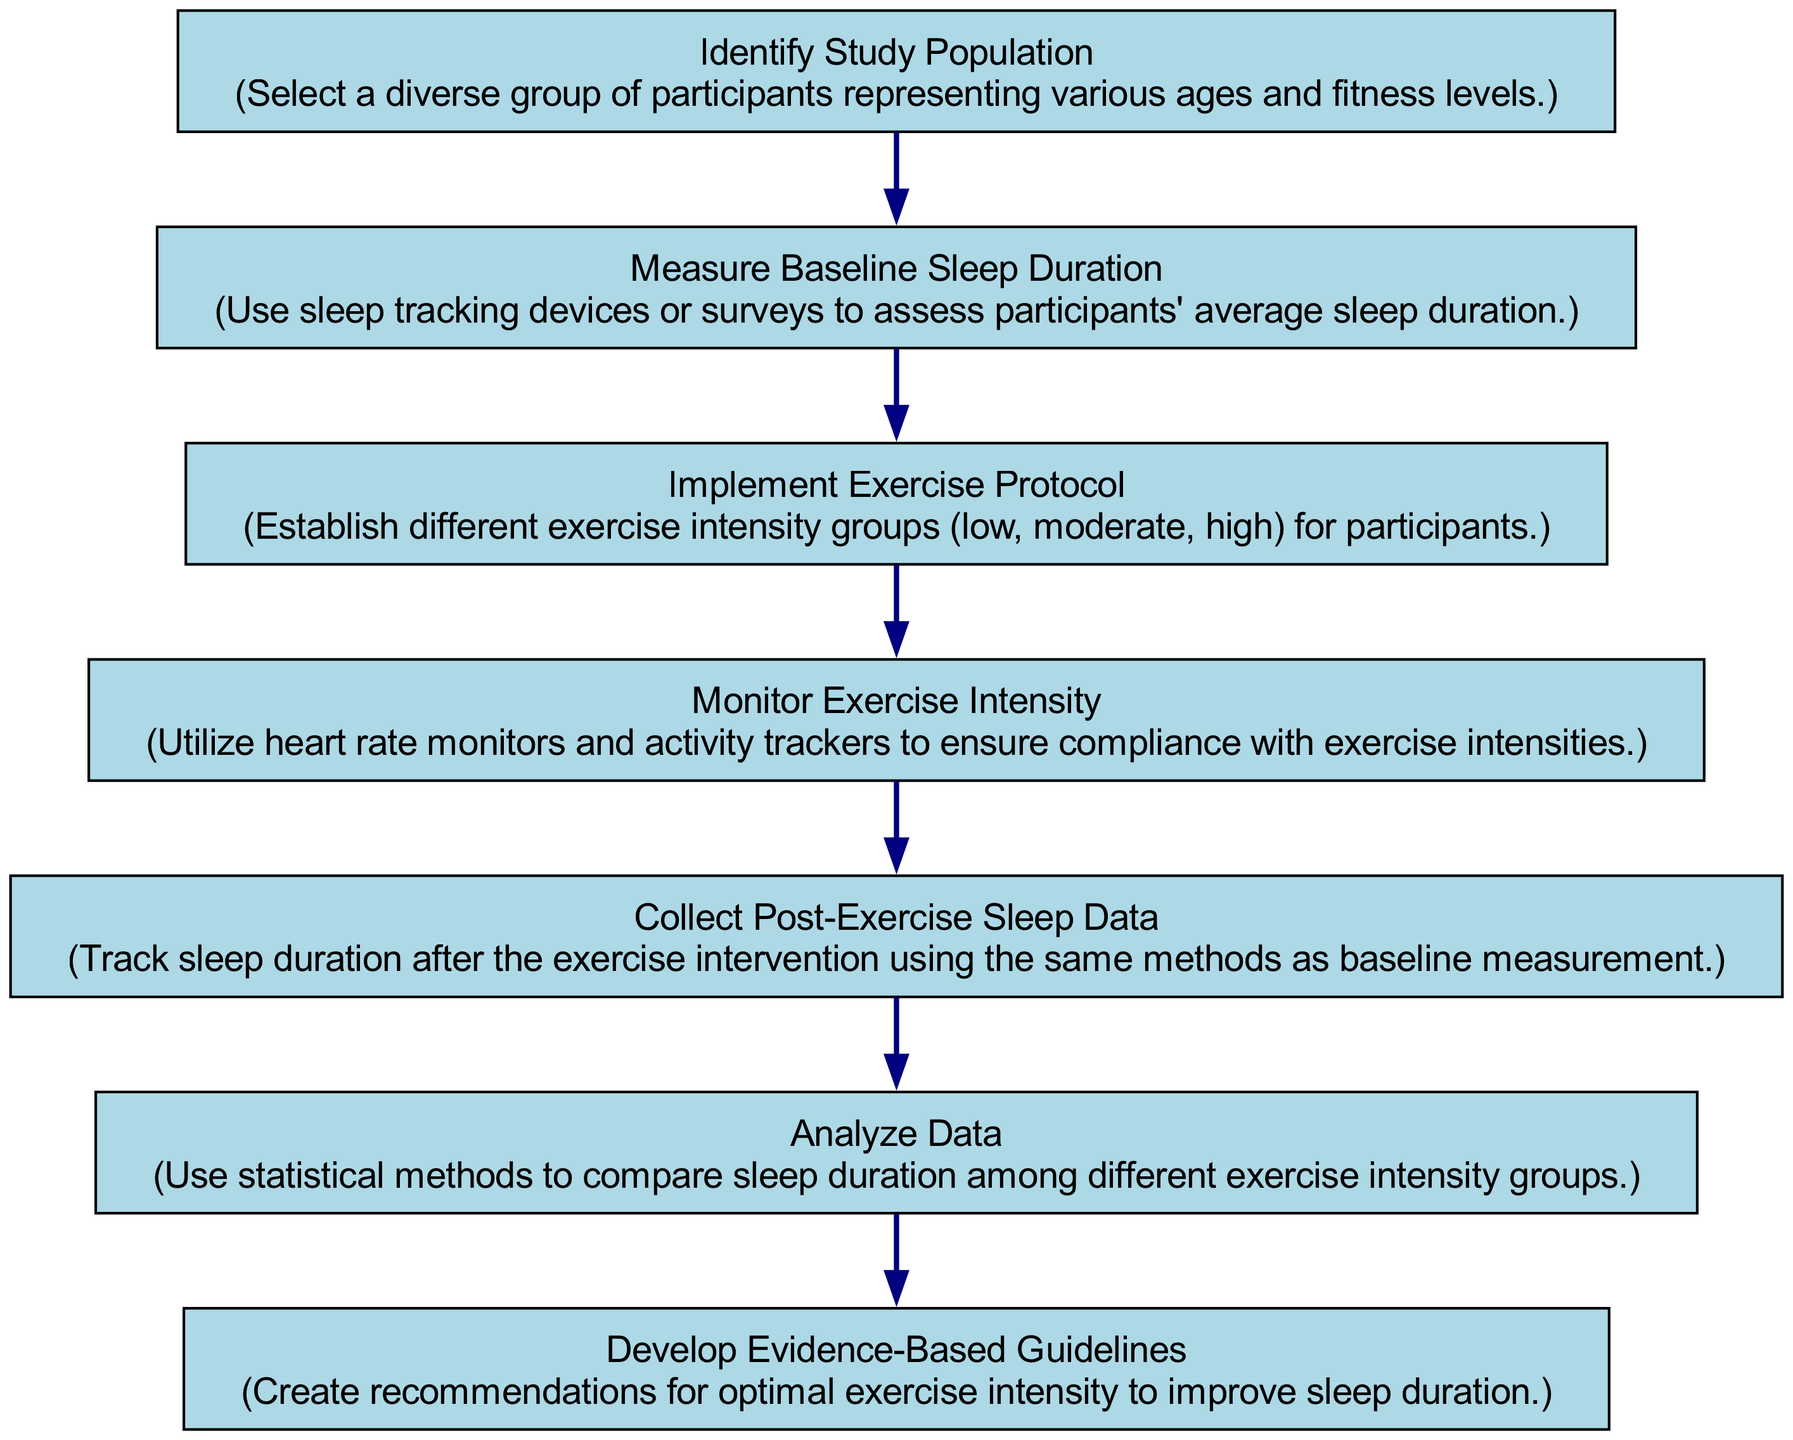What is the first step in the flow chart? The first step in the flow chart is "Identify Study Population." This can be directly observed from the topmost node in the diagram, which clearly states this label.
Answer: Identify Study Population How many nodes are present in the flow chart? There are a total of seven nodes in the flow chart. By counting each labeled step from "Identify Study Population" to "Develop Evidence-Based Guidelines," we reach the total of seven.
Answer: Seven Which node follows "Measure Baseline Sleep Duration"? The node that follows "Measure Baseline Sleep Duration" is "Implement Exercise Protocol." This sequence can be traced by looking at the directed flow from one node to the next.
Answer: Implement Exercise Protocol What is the last step in the process? The last step in the process is "Develop Evidence-Based Guidelines." This can be identified as the final node in the flowchart sequence that culminates the research process.
Answer: Develop Evidence-Based Guidelines What methods are used to measure baseline sleep duration? The methods referred to in the flow chart include "sleep tracking devices or surveys." This information is presented directly within the description of the "Measure Baseline Sleep Duration" node.
Answer: Sleep tracking devices or surveys How is exercise intensity monitored during the study? Exercise intensity is monitored using "heart rate monitors and activity trackers." This detail is outlined in the description of the "Monitor Exercise Intensity" node, indicating the tools used for this purpose.
Answer: Heart rate monitors and activity trackers What action is taken after collecting post-exercise sleep data? After collecting post-exercise sleep data, the next action taken is to "Analyze Data." This relationship is established by following the flow from the post-exercise data collection to the subsequent analysis node.
Answer: Analyze Data What type of guidelines are developed at the end of the flow chart? The guidelines developed at the end of the flow chart are "Evidence-Based Guidelines." This can be deduced from the final node's label, which clearly states the nature of the guidelines.
Answer: Evidence-Based Guidelines 